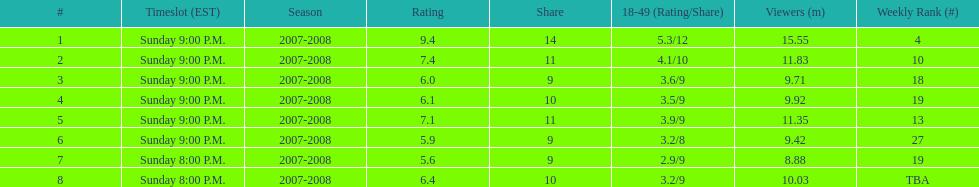How many shows had at least 10 million viewers? 4. 